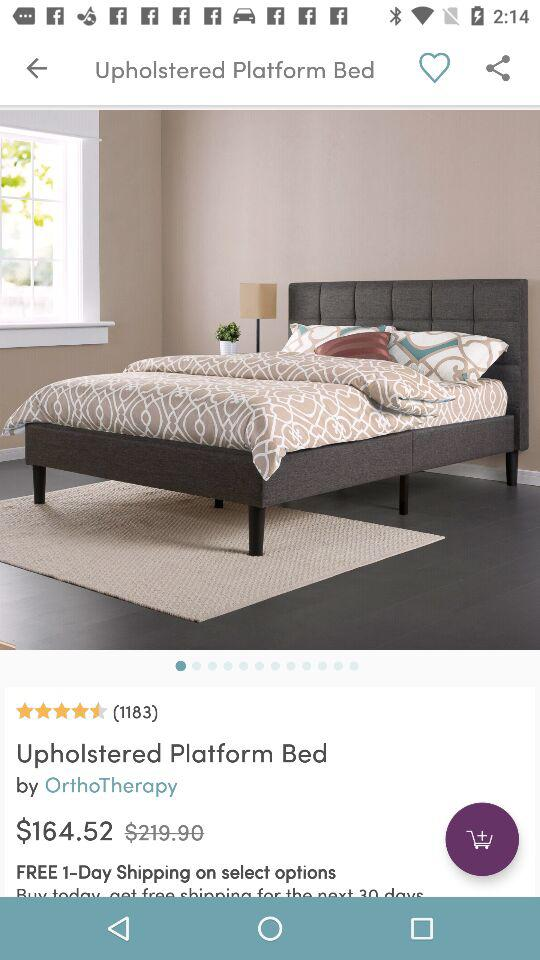What is the rating? The rating is 4.5 stars. 